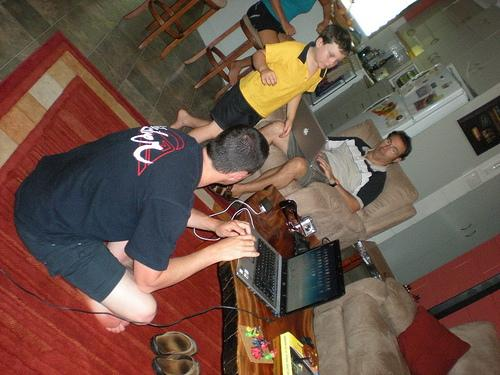What company made the silver laptop the man on the couch is using?

Choices:
A) microsoft
B) apple
C) hp
D) dell apple 